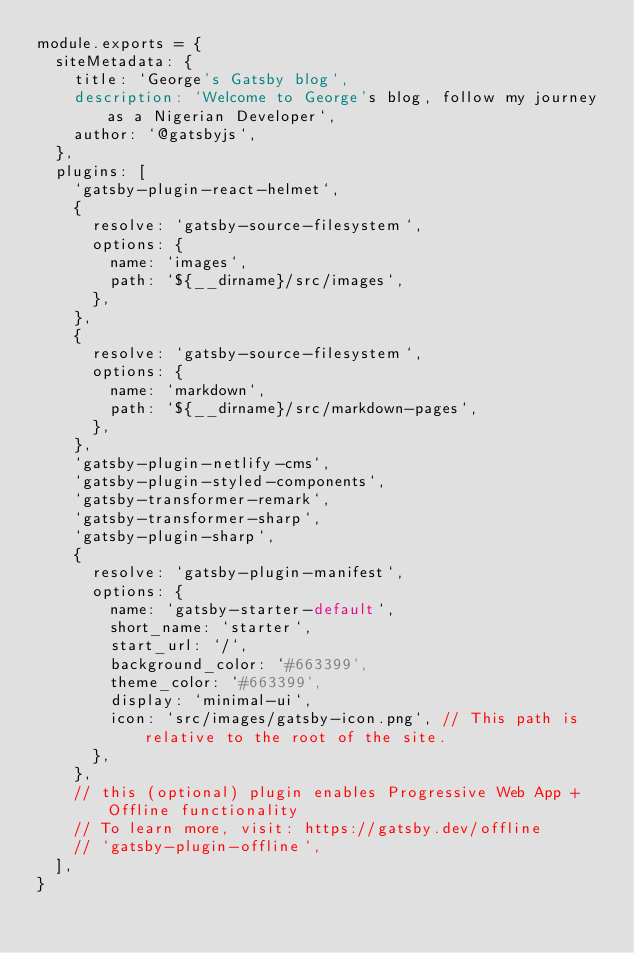Convert code to text. <code><loc_0><loc_0><loc_500><loc_500><_JavaScript_>module.exports = {
  siteMetadata: {
    title: `George's Gatsby blog`,
    description: `Welcome to George's blog, follow my journey as a Nigerian Developer`,
    author: `@gatsbyjs`,
  },
  plugins: [
    `gatsby-plugin-react-helmet`,
    {
      resolve: `gatsby-source-filesystem`,
      options: {
        name: `images`,
        path: `${__dirname}/src/images`,
      },
    },
    {
      resolve: `gatsby-source-filesystem`,
      options: {
        name: `markdown`,
        path: `${__dirname}/src/markdown-pages`,
      },
    },
    `gatsby-plugin-netlify-cms`,
    `gatsby-plugin-styled-components`,
    `gatsby-transformer-remark`,
    `gatsby-transformer-sharp`,
    `gatsby-plugin-sharp`,
    {
      resolve: `gatsby-plugin-manifest`,
      options: {
        name: `gatsby-starter-default`,
        short_name: `starter`,
        start_url: `/`,
        background_color: `#663399`,
        theme_color: `#663399`,
        display: `minimal-ui`,
        icon: `src/images/gatsby-icon.png`, // This path is relative to the root of the site.
      },
    },
    // this (optional) plugin enables Progressive Web App + Offline functionality
    // To learn more, visit: https://gatsby.dev/offline
    // `gatsby-plugin-offline`,
  ],
}
</code> 